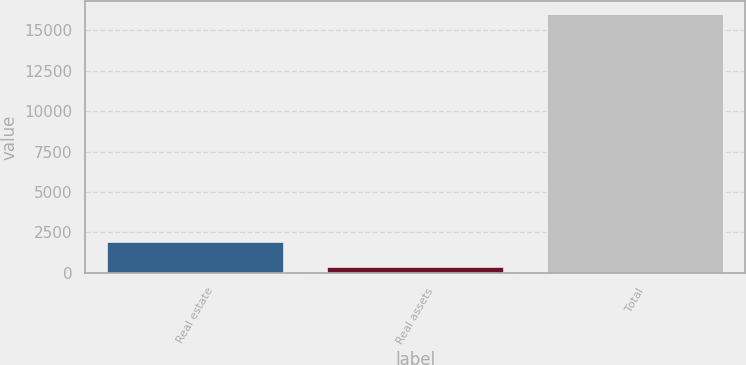Convert chart to OTSL. <chart><loc_0><loc_0><loc_500><loc_500><bar_chart><fcel>Real estate<fcel>Real assets<fcel>Total<nl><fcel>1901.5<fcel>336<fcel>15991<nl></chart> 